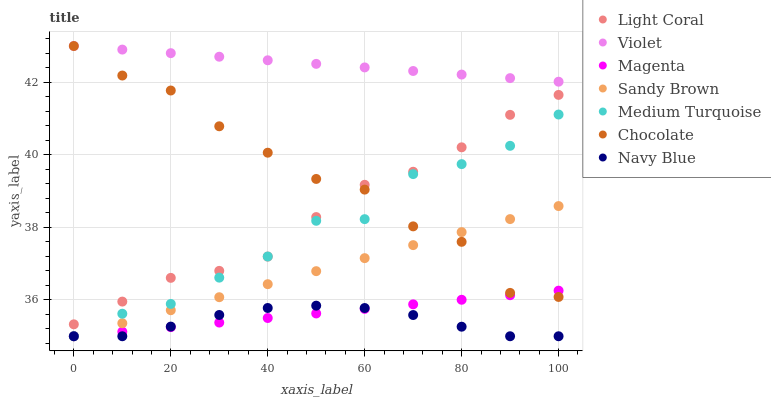Does Navy Blue have the minimum area under the curve?
Answer yes or no. Yes. Does Violet have the maximum area under the curve?
Answer yes or no. Yes. Does Chocolate have the minimum area under the curve?
Answer yes or no. No. Does Chocolate have the maximum area under the curve?
Answer yes or no. No. Is Sandy Brown the smoothest?
Answer yes or no. Yes. Is Chocolate the roughest?
Answer yes or no. Yes. Is Light Coral the smoothest?
Answer yes or no. No. Is Light Coral the roughest?
Answer yes or no. No. Does Navy Blue have the lowest value?
Answer yes or no. Yes. Does Chocolate have the lowest value?
Answer yes or no. No. Does Violet have the highest value?
Answer yes or no. Yes. Does Light Coral have the highest value?
Answer yes or no. No. Is Light Coral less than Violet?
Answer yes or no. Yes. Is Chocolate greater than Navy Blue?
Answer yes or no. Yes. Does Medium Turquoise intersect Navy Blue?
Answer yes or no. Yes. Is Medium Turquoise less than Navy Blue?
Answer yes or no. No. Is Medium Turquoise greater than Navy Blue?
Answer yes or no. No. Does Light Coral intersect Violet?
Answer yes or no. No. 